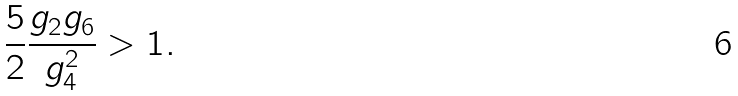Convert formula to latex. <formula><loc_0><loc_0><loc_500><loc_500>\frac { 5 } { 2 } \frac { g _ { 2 } g _ { 6 } } { g _ { 4 } ^ { 2 } } > 1 .</formula> 